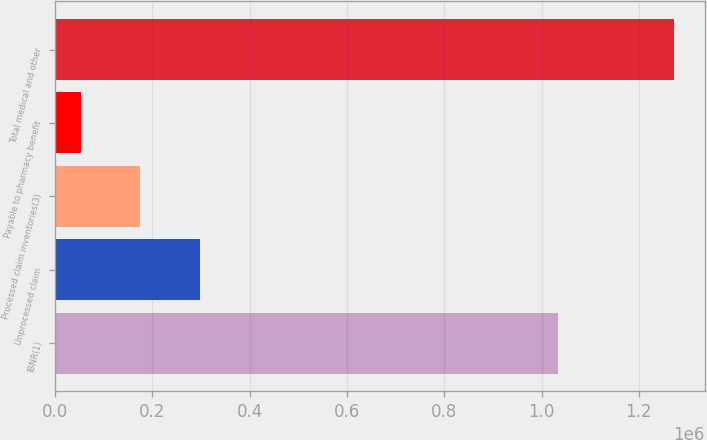Convert chart. <chart><loc_0><loc_0><loc_500><loc_500><bar_chart><fcel>IBNR(1)<fcel>Unprocessed claim<fcel>Processed claim inventories(3)<fcel>Payable to pharmacy benefit<fcel>Total medical and other<nl><fcel>1.03486e+06<fcel>297100<fcel>175218<fcel>53336<fcel>1.27216e+06<nl></chart> 